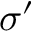Convert formula to latex. <formula><loc_0><loc_0><loc_500><loc_500>\sigma ^ { \prime }</formula> 